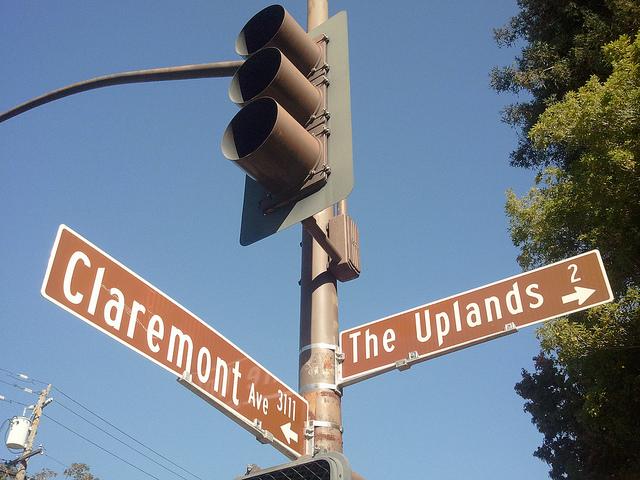What streets are these?
Be succinct. Claremont and uplands. What is the object hanging over the street signs?
Short answer required. Traffic light. What is beneath the power lines on the power pole?
Write a very short answer. Transformer. Does the stoplight say to go or stop?
Answer briefly. Stop. Where will a person be by going to the right?
Concise answer only. Uplands. 